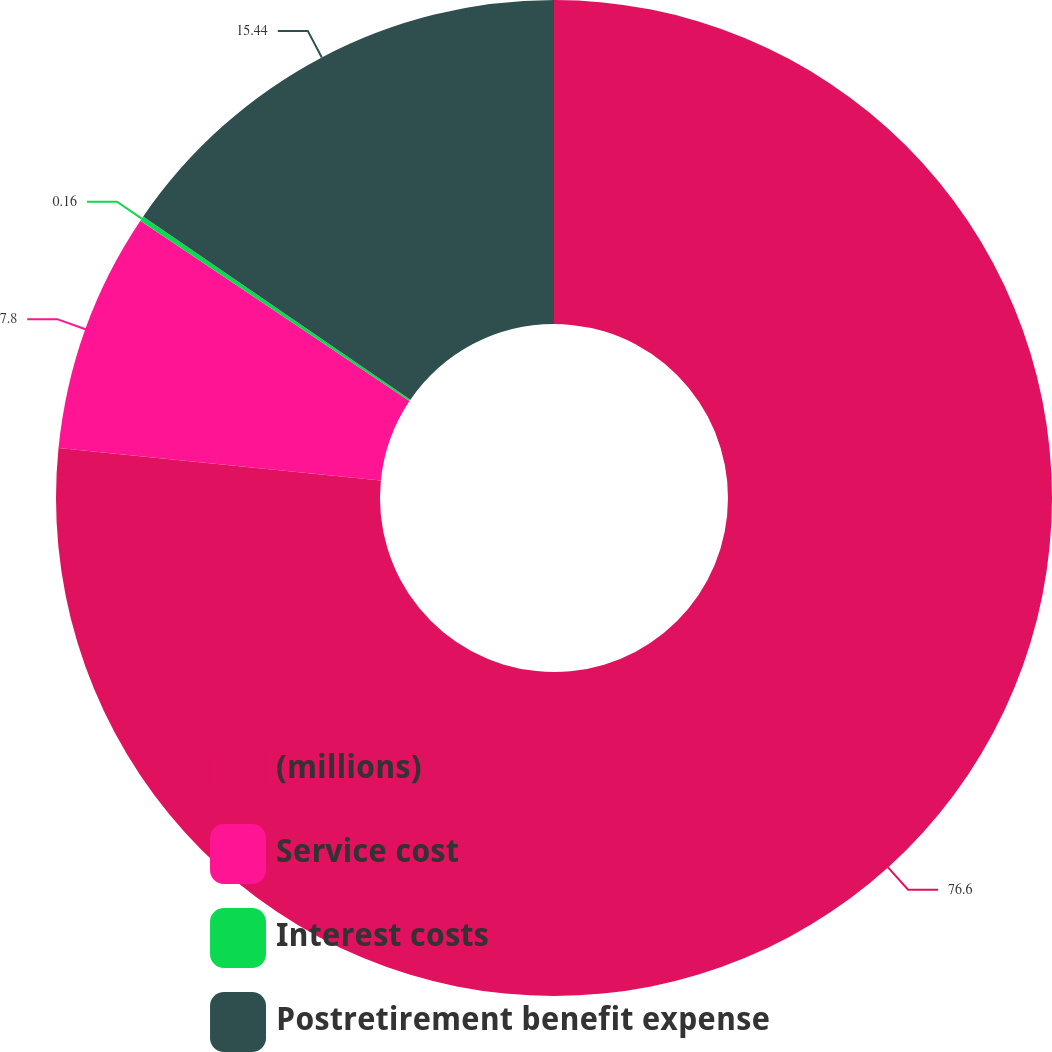Convert chart to OTSL. <chart><loc_0><loc_0><loc_500><loc_500><pie_chart><fcel>(millions)<fcel>Service cost<fcel>Interest costs<fcel>Postretirement benefit expense<nl><fcel>76.6%<fcel>7.8%<fcel>0.16%<fcel>15.44%<nl></chart> 